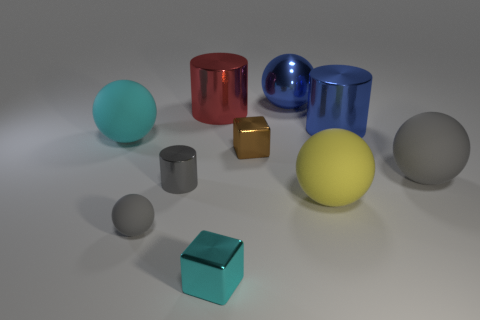How many objects are either cyan rubber objects or small things behind the big yellow rubber thing?
Offer a very short reply. 3. There is a gray cylinder that is made of the same material as the brown object; what size is it?
Your answer should be compact. Small. The big blue object that is left of the blue thing right of the large blue ball is what shape?
Your answer should be very brief. Sphere. What number of gray things are tiny metal cubes or tiny spheres?
Ensure brevity in your answer.  1. There is a gray matte thing on the right side of the small cube left of the tiny brown metallic thing; is there a big yellow thing behind it?
Offer a very short reply. No. There is a big thing that is the same color as the metal sphere; what shape is it?
Give a very brief answer. Cylinder. How many large things are either brown metal blocks or spheres?
Offer a very short reply. 4. Is the shape of the tiny gray thing left of the gray cylinder the same as  the big gray rubber object?
Offer a very short reply. Yes. Are there fewer small gray matte things than big matte objects?
Offer a very short reply. Yes. What shape is the rubber object that is behind the large gray object?
Provide a succinct answer. Sphere. 